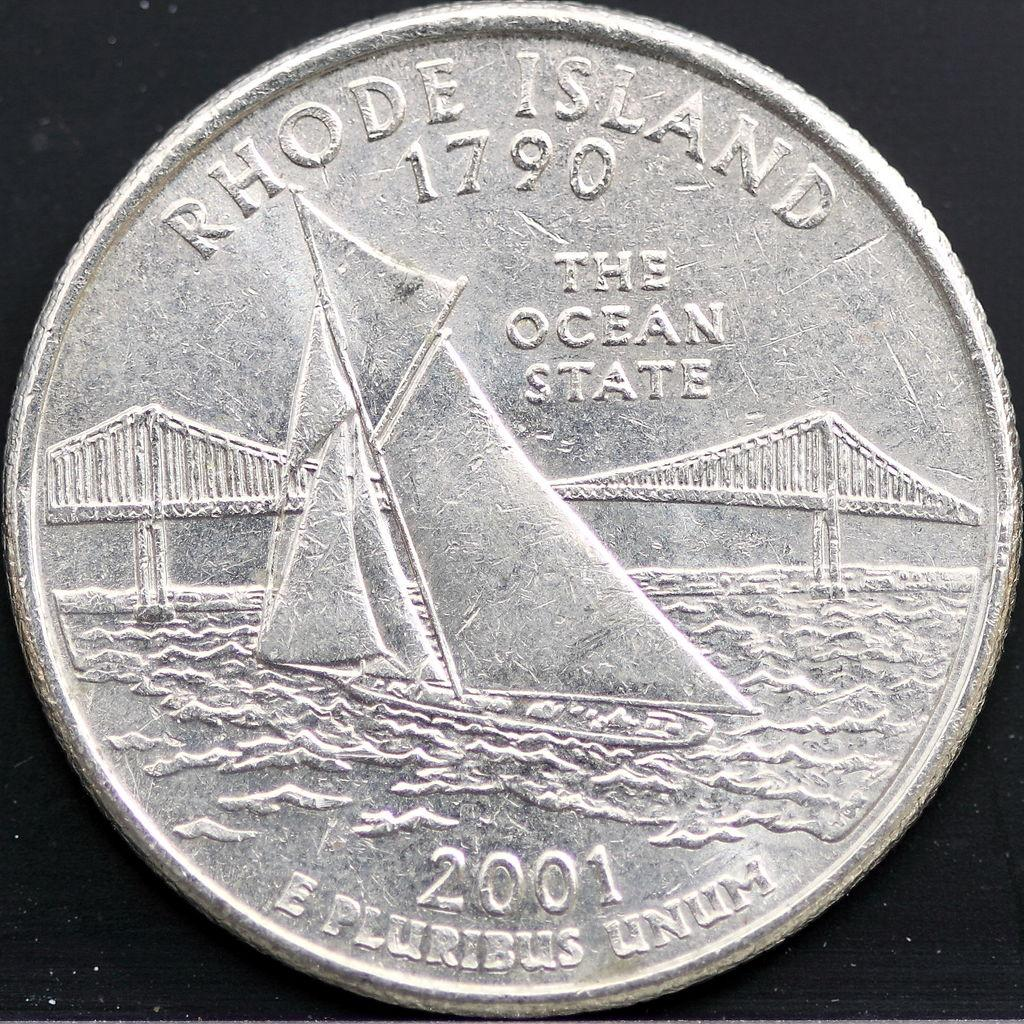<image>
Render a clear and concise summary of the photo. a silver coin that says 'rhode island' 1790 on it 